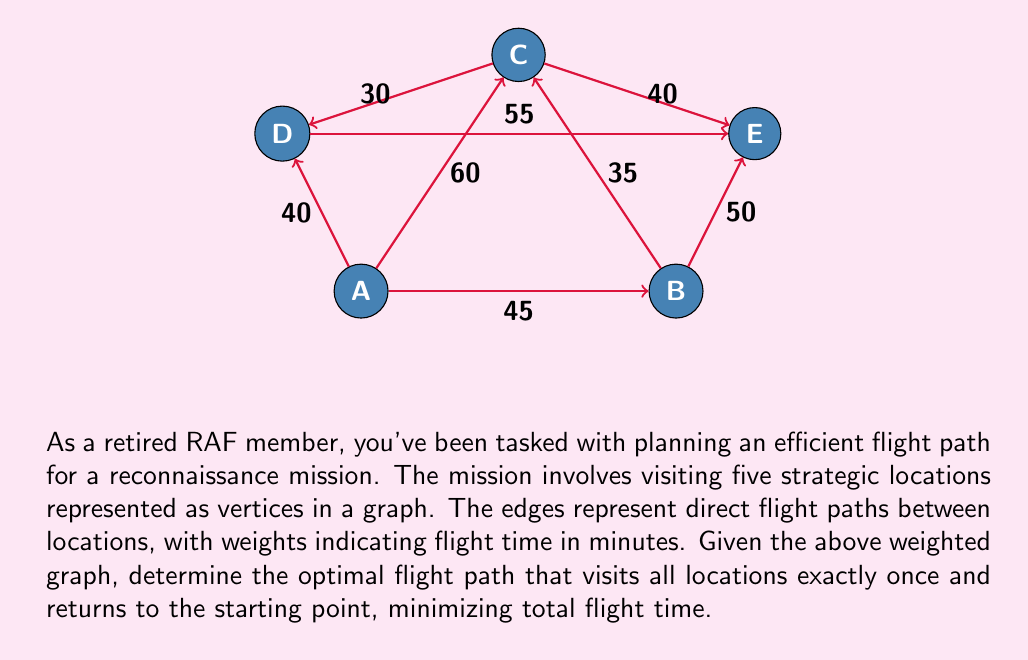Can you solve this math problem? To solve this problem, we need to find the Hamiltonian cycle with the minimum total weight in the given graph. This is known as the Traveling Salesman Problem (TSP), which is NP-hard. For a small graph like this, we can use a brute-force approach to find the optimal solution.

Steps to solve:

1) List all possible Hamiltonian cycles starting and ending at A:
   A-B-C-D-E-A
   A-B-C-E-D-A
   A-B-E-C-D-A
   A-B-E-D-C-A
   A-C-B-E-D-A
   A-C-D-E-B-A
   A-C-E-B-D-A
   A-C-E-D-B-A
   A-D-C-B-E-A
   A-D-C-E-B-A
   A-D-E-B-C-A
   A-D-E-C-B-A

2) Calculate the total flight time for each cycle:

   A-B-C-D-E-A: 45 + 35 + 30 + 55 + 50 = 215 minutes
   A-B-C-E-D-A: 45 + 35 + 40 + 55 + 40 = 215 minutes
   A-B-E-C-D-A: 45 + 50 + 40 + 30 + 40 = 205 minutes
   A-B-E-D-C-A: 45 + 50 + 55 + 30 + 60 = 240 minutes
   A-C-B-E-D-A: 60 + 35 + 50 + 55 + 40 = 240 minutes
   A-C-D-E-B-A: 60 + 30 + 55 + 50 + 45 = 240 minutes
   A-C-E-B-D-A: 60 + 40 + 50 + 45 + 40 = 235 minutes
   A-C-E-D-B-A: 60 + 40 + 55 + 45 + 45 = 245 minutes
   A-D-C-B-E-A: 40 + 30 + 35 + 50 + 50 = 205 minutes
   A-D-C-E-B-A: 40 + 30 + 40 + 50 + 45 = 205 minutes
   A-D-E-B-C-A: 40 + 55 + 50 + 35 + 60 = 240 minutes
   A-D-E-C-B-A: 40 + 55 + 40 + 35 + 45 = 215 minutes

3) Identify the cycle(s) with the minimum total flight time.

The optimal flight paths are:
A-B-E-C-D-A
A-D-C-B-E-A
A-D-C-E-B-A

All these paths have a total flight time of 205 minutes.
Answer: The optimal flight path(s) with a total flight time of 205 minutes are:
$$\text{A} \rightarrow \text{B} \rightarrow \text{E} \rightarrow \text{C} \rightarrow \text{D} \rightarrow \text{A}$$
$$\text{A} \rightarrow \text{D} \rightarrow \text{C} \rightarrow \text{B} \rightarrow \text{E} \rightarrow \text{A}$$
$$\text{A} \rightarrow \text{D} \rightarrow \text{C} \rightarrow \text{E} \rightarrow \text{B} \rightarrow \text{A}$$ 